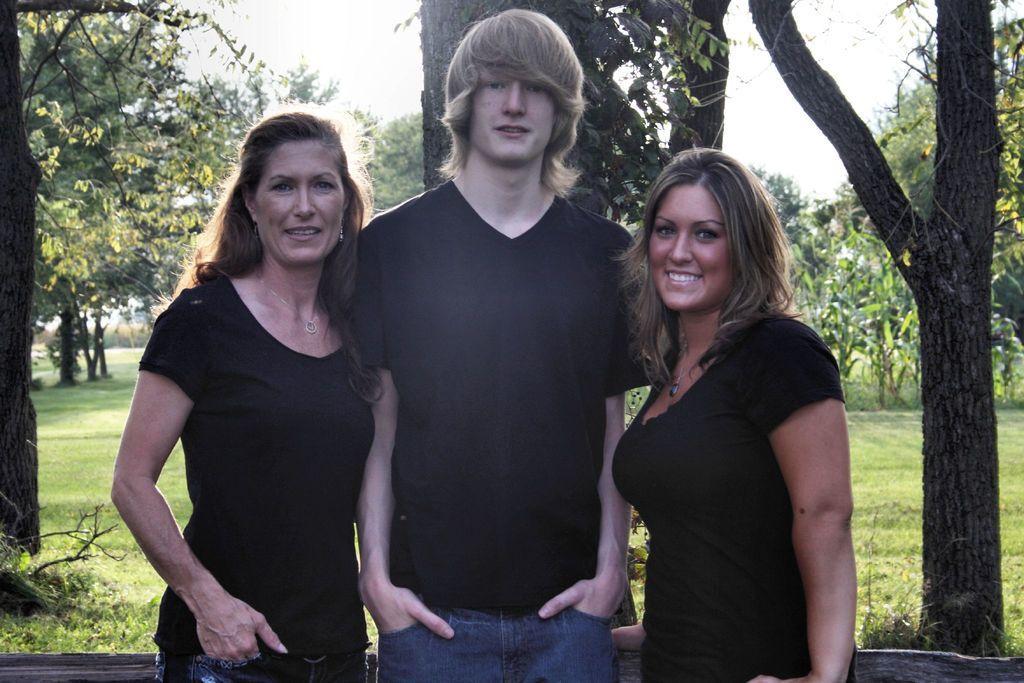Could you give a brief overview of what you see in this image? These three people are standing. Background there are trees and grass. 